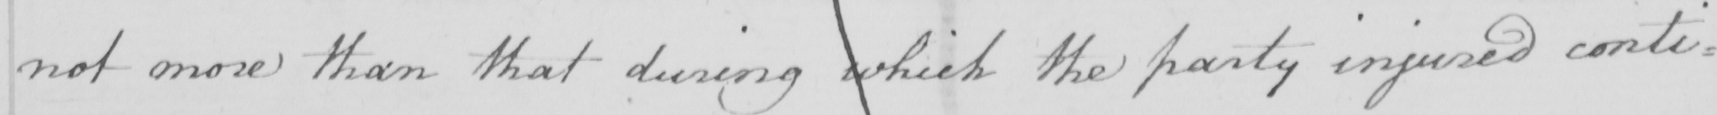What is written in this line of handwriting? not more than that during which the party injured conti= 